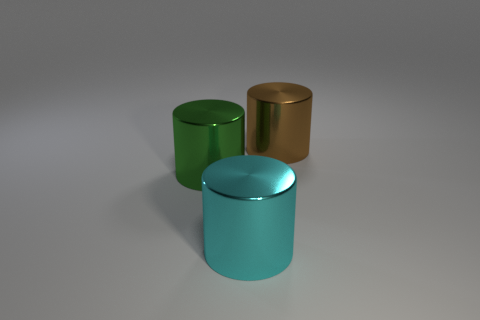There is a cylinder that is in front of the large green metal cylinder; is there a large cyan shiny thing that is in front of it?
Ensure brevity in your answer.  No. Are there any big green things?
Offer a very short reply. Yes. How many metal cylinders are the same size as the cyan thing?
Provide a short and direct response. 2. How many things are both right of the green thing and left of the big brown shiny cylinder?
Give a very brief answer. 1. Does the metal cylinder that is left of the cyan cylinder have the same size as the big cyan cylinder?
Provide a succinct answer. Yes. The cyan cylinder that is made of the same material as the big green cylinder is what size?
Give a very brief answer. Large. Is the number of green cylinders that are in front of the green object greater than the number of cyan cylinders to the left of the large brown shiny object?
Your answer should be very brief. No. How many other things are there of the same material as the green cylinder?
Ensure brevity in your answer.  2. Does the large thing that is on the right side of the cyan metallic thing have the same material as the big green cylinder?
Offer a very short reply. Yes. Are there more big metal cylinders left of the large brown metallic thing than brown shiny cylinders?
Your answer should be compact. Yes. 